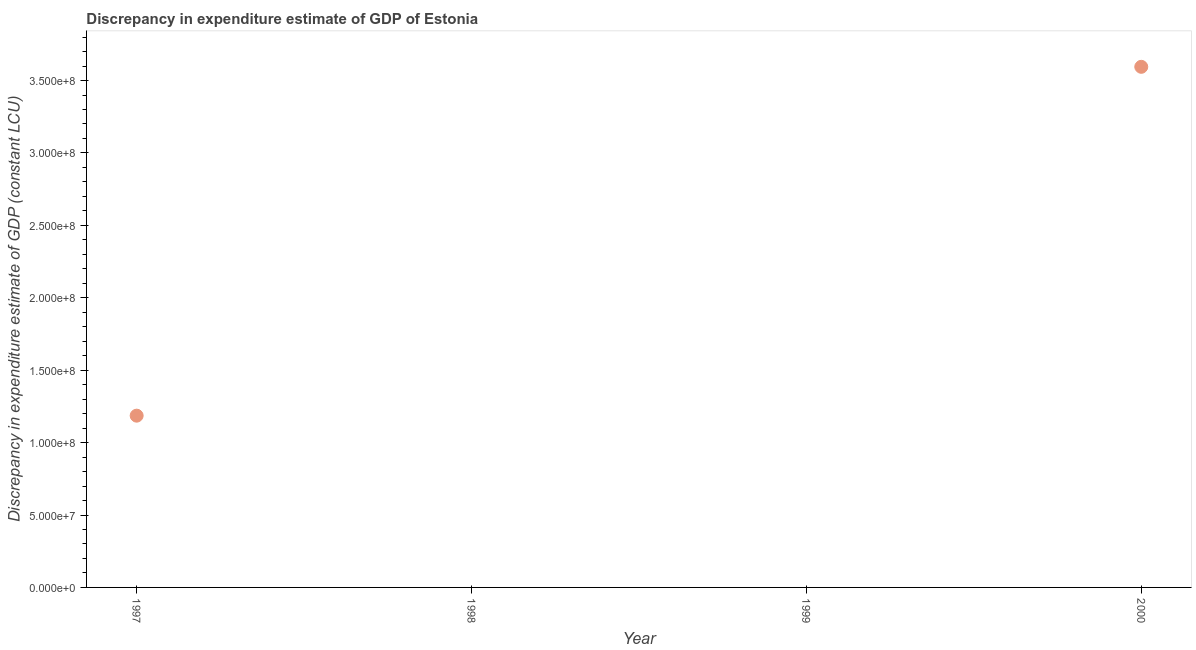What is the discrepancy in expenditure estimate of gdp in 2000?
Your response must be concise. 3.59e+08. Across all years, what is the maximum discrepancy in expenditure estimate of gdp?
Your answer should be compact. 3.59e+08. In which year was the discrepancy in expenditure estimate of gdp maximum?
Make the answer very short. 2000. What is the sum of the discrepancy in expenditure estimate of gdp?
Offer a terse response. 4.78e+08. What is the difference between the discrepancy in expenditure estimate of gdp in 1997 and 2000?
Give a very brief answer. -2.41e+08. What is the average discrepancy in expenditure estimate of gdp per year?
Provide a short and direct response. 1.20e+08. What is the median discrepancy in expenditure estimate of gdp?
Your answer should be very brief. 5.93e+07. What is the ratio of the discrepancy in expenditure estimate of gdp in 1997 to that in 2000?
Your answer should be very brief. 0.33. Is the discrepancy in expenditure estimate of gdp in 1997 less than that in 2000?
Offer a terse response. Yes. Is the difference between the discrepancy in expenditure estimate of gdp in 1997 and 2000 greater than the difference between any two years?
Ensure brevity in your answer.  No. What is the difference between the highest and the lowest discrepancy in expenditure estimate of gdp?
Keep it short and to the point. 3.59e+08. In how many years, is the discrepancy in expenditure estimate of gdp greater than the average discrepancy in expenditure estimate of gdp taken over all years?
Your answer should be very brief. 1. How many dotlines are there?
Keep it short and to the point. 1. How many years are there in the graph?
Offer a terse response. 4. What is the title of the graph?
Give a very brief answer. Discrepancy in expenditure estimate of GDP of Estonia. What is the label or title of the X-axis?
Ensure brevity in your answer.  Year. What is the label or title of the Y-axis?
Your answer should be compact. Discrepancy in expenditure estimate of GDP (constant LCU). What is the Discrepancy in expenditure estimate of GDP (constant LCU) in 1997?
Your answer should be compact. 1.19e+08. What is the Discrepancy in expenditure estimate of GDP (constant LCU) in 2000?
Make the answer very short. 3.59e+08. What is the difference between the Discrepancy in expenditure estimate of GDP (constant LCU) in 1997 and 2000?
Your answer should be compact. -2.41e+08. What is the ratio of the Discrepancy in expenditure estimate of GDP (constant LCU) in 1997 to that in 2000?
Offer a very short reply. 0.33. 